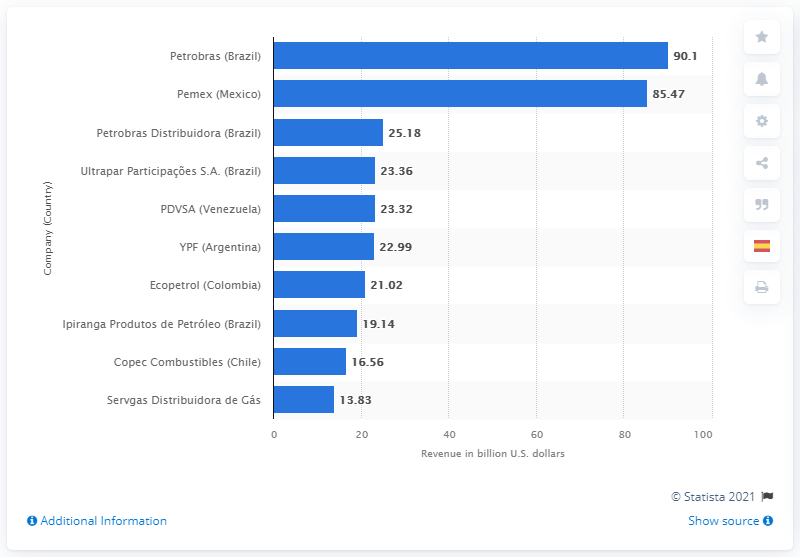Point out several critical features in this image. Petrobras generated approximately $90.1 million in revenue in the United States in 2018. 